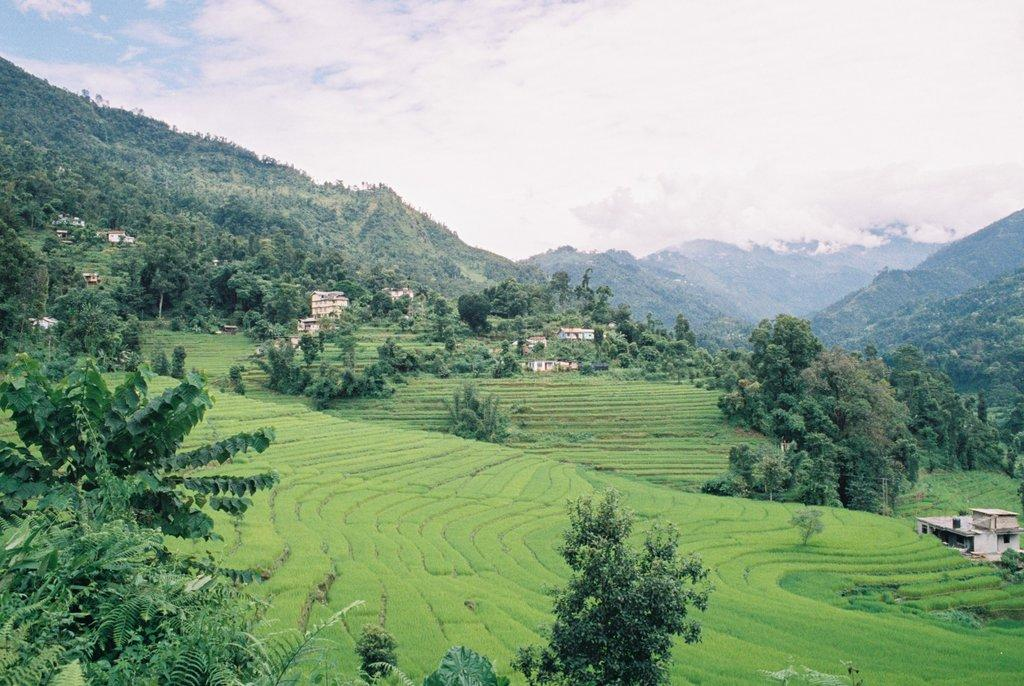What type of living organisms can be seen in the image? Plants can be seen in the image. What type of structures are present in the image? There are houses and buildings in the image. Where are the trees located in the image? There is a group of trees on the hills in the image. How does the sky appear in the image? The sky is visible in the image and appears cloudy. What type of jewel is embedded in the hydrant in the image? There is no hydrant or jewel present in the image. 